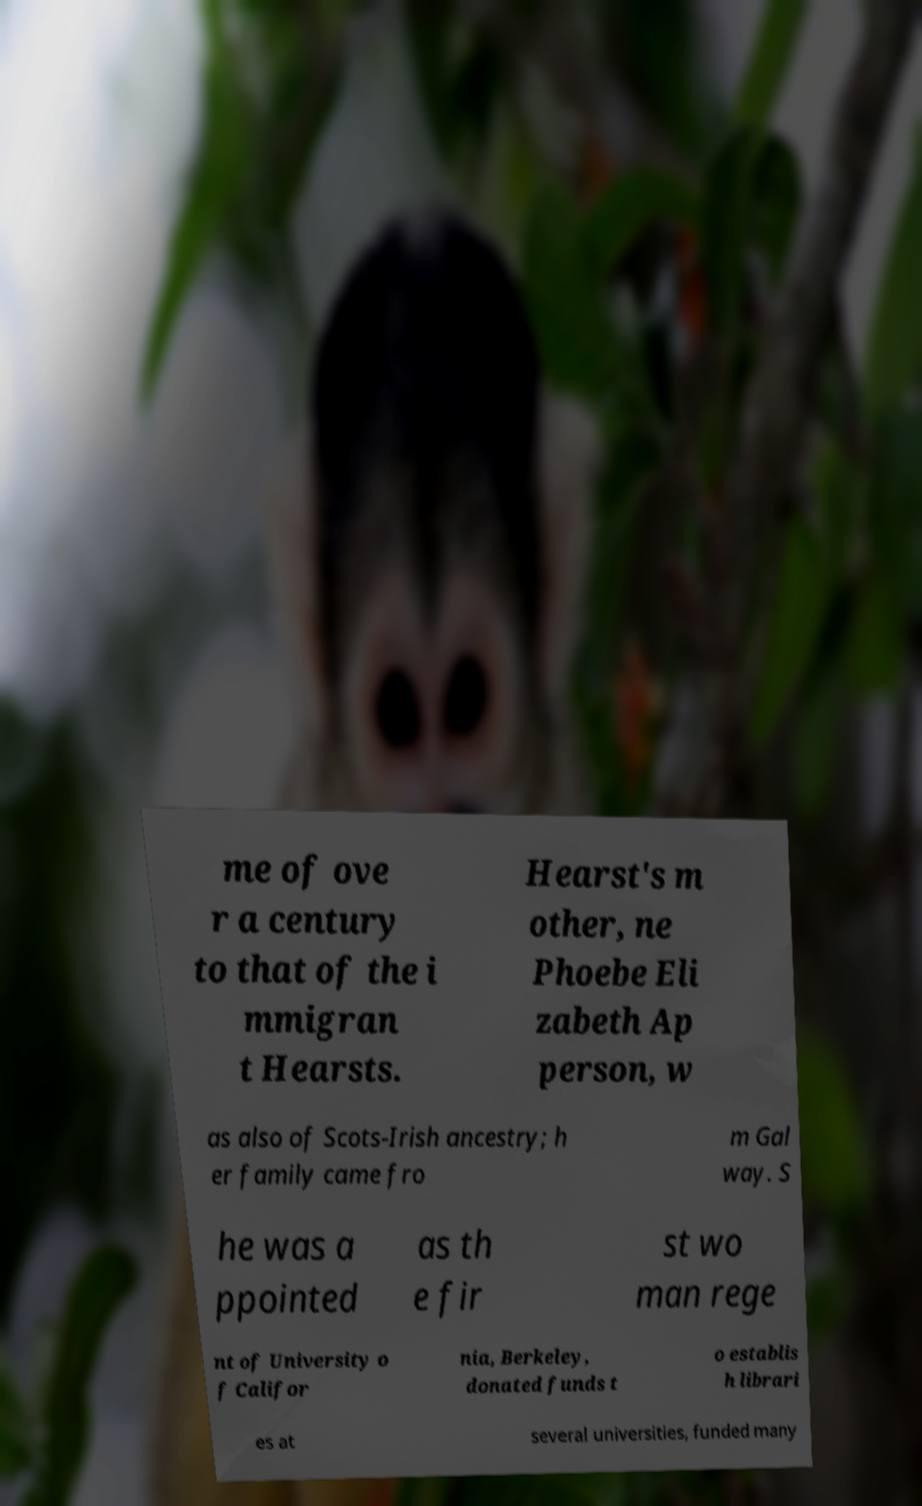Could you extract and type out the text from this image? me of ove r a century to that of the i mmigran t Hearsts. Hearst's m other, ne Phoebe Eli zabeth Ap person, w as also of Scots-Irish ancestry; h er family came fro m Gal way. S he was a ppointed as th e fir st wo man rege nt of University o f Califor nia, Berkeley, donated funds t o establis h librari es at several universities, funded many 